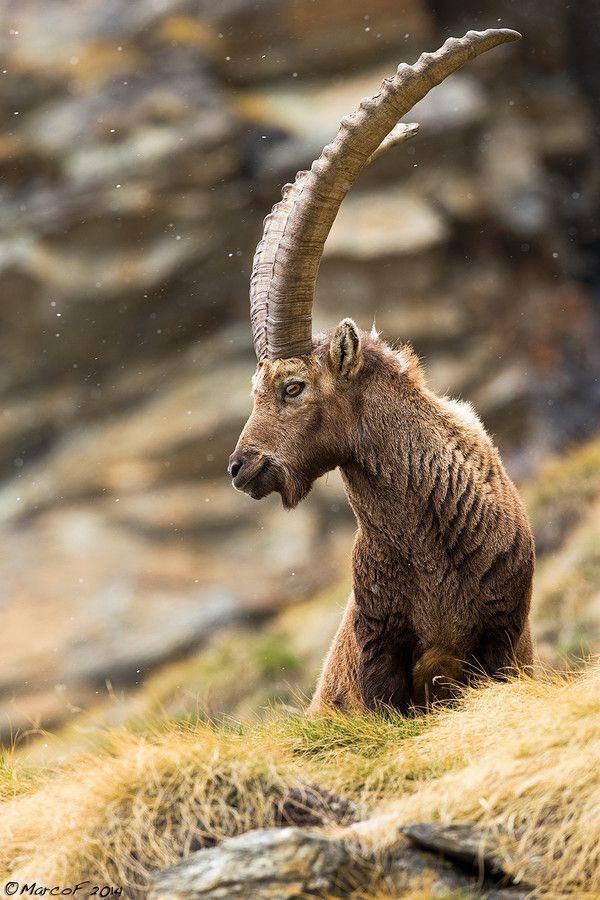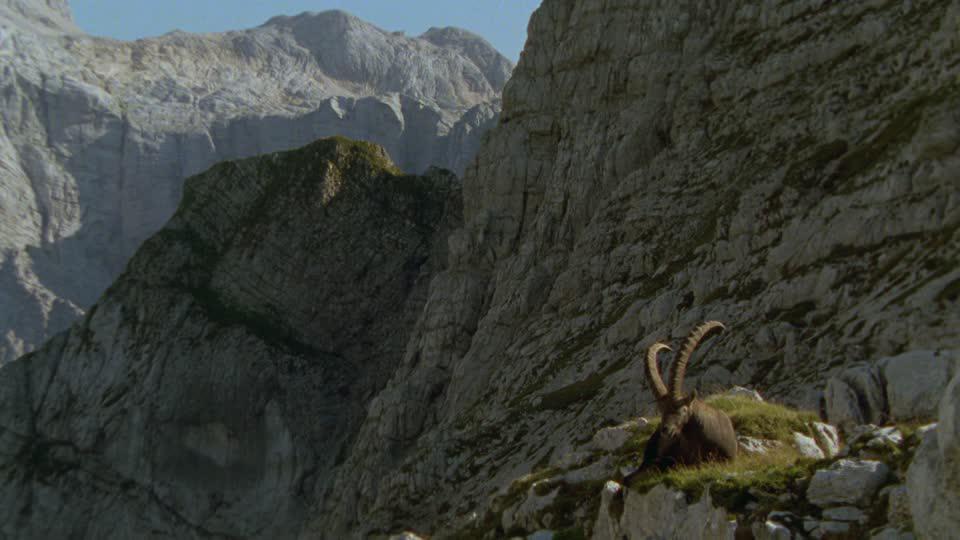The first image is the image on the left, the second image is the image on the right. Considering the images on both sides, is "Left image shows exactly one horned animal, with both horns showing clearly and separately." valid? Answer yes or no. No. 